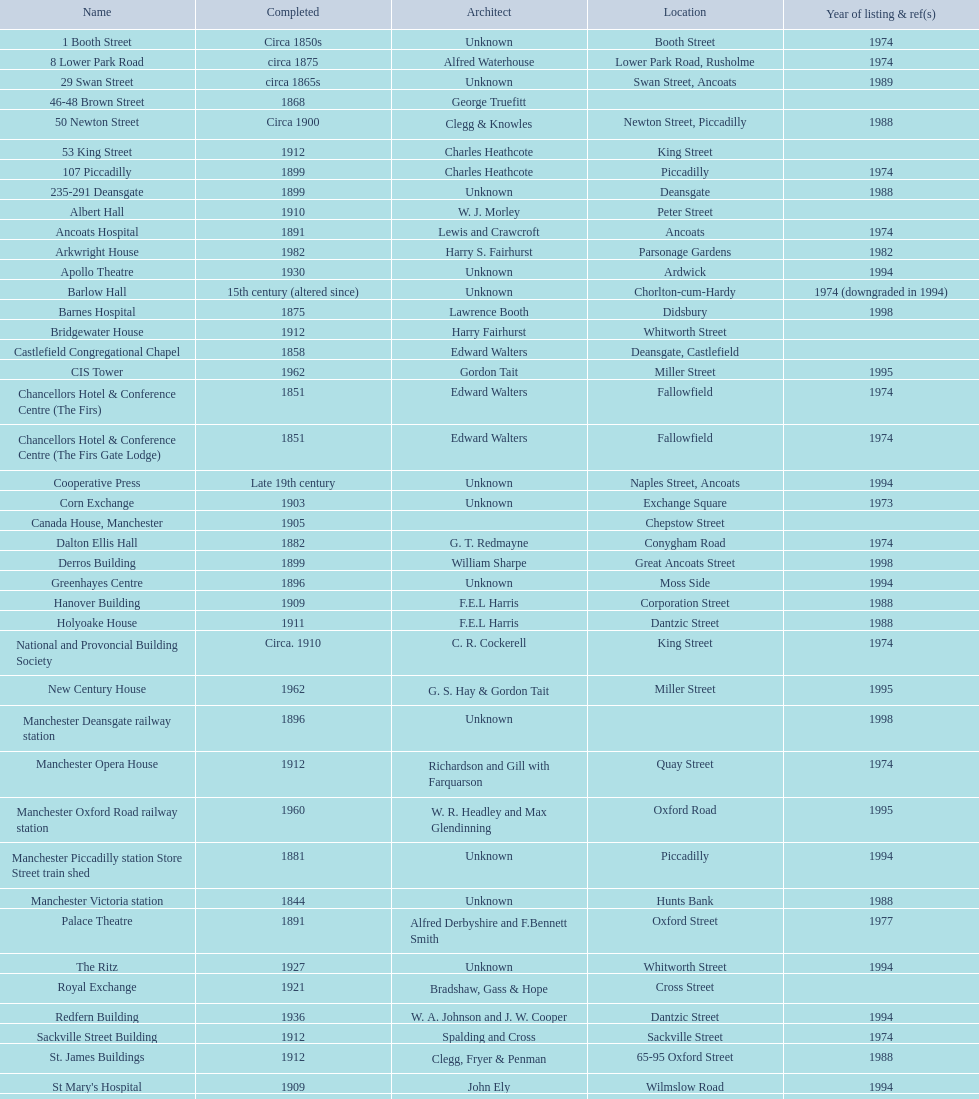Is charles heathcote the architect responsible for ancoats hospital and apollo theatre? No. 